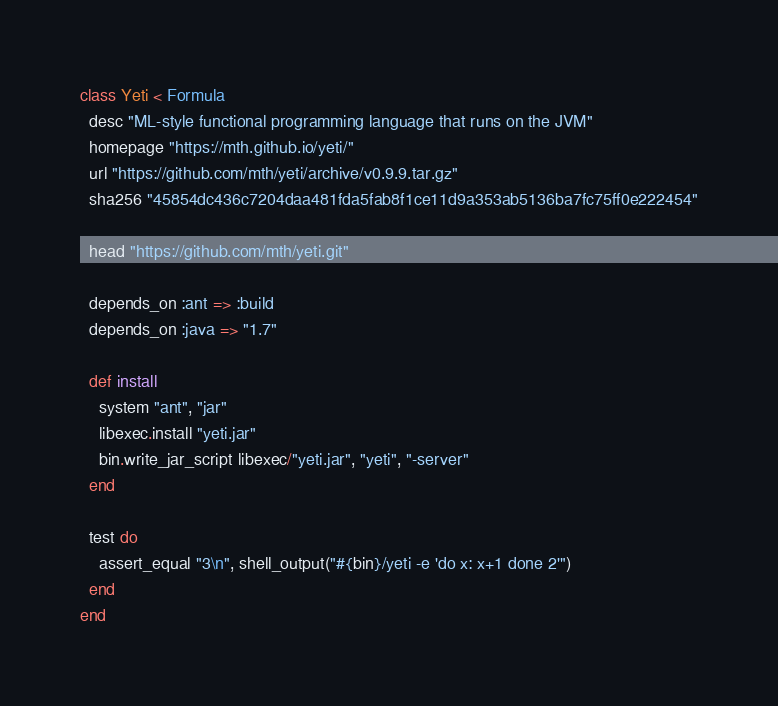<code> <loc_0><loc_0><loc_500><loc_500><_Ruby_>class Yeti < Formula
  desc "ML-style functional programming language that runs on the JVM"
  homepage "https://mth.github.io/yeti/"
  url "https://github.com/mth/yeti/archive/v0.9.9.tar.gz"
  sha256 "45854dc436c7204daa481fda5fab8f1ce11d9a353ab5136ba7fc75ff0e222454"

  head "https://github.com/mth/yeti.git"

  depends_on :ant => :build
  depends_on :java => "1.7"

  def install
    system "ant", "jar"
    libexec.install "yeti.jar"
    bin.write_jar_script libexec/"yeti.jar", "yeti", "-server"
  end

  test do
    assert_equal "3\n", shell_output("#{bin}/yeti -e 'do x: x+1 done 2'")
  end
end
</code> 